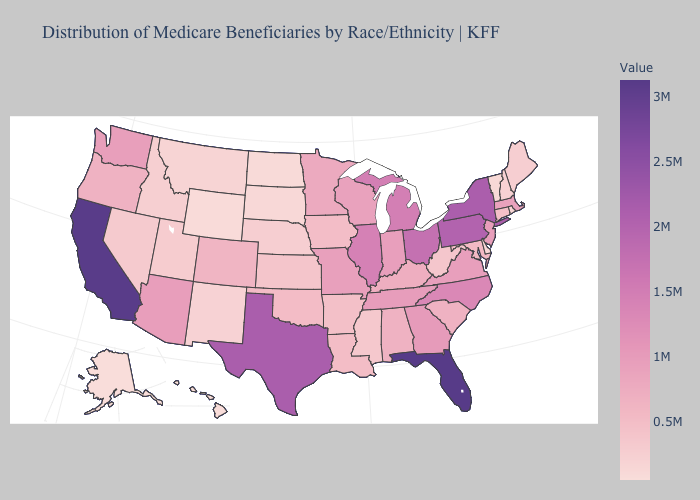Does South Dakota have the highest value in the MidWest?
Answer briefly. No. Does California have the lowest value in the West?
Be succinct. No. Does Idaho have a higher value than Georgia?
Short answer required. No. Does Louisiana have a higher value than Arizona?
Keep it brief. No. 